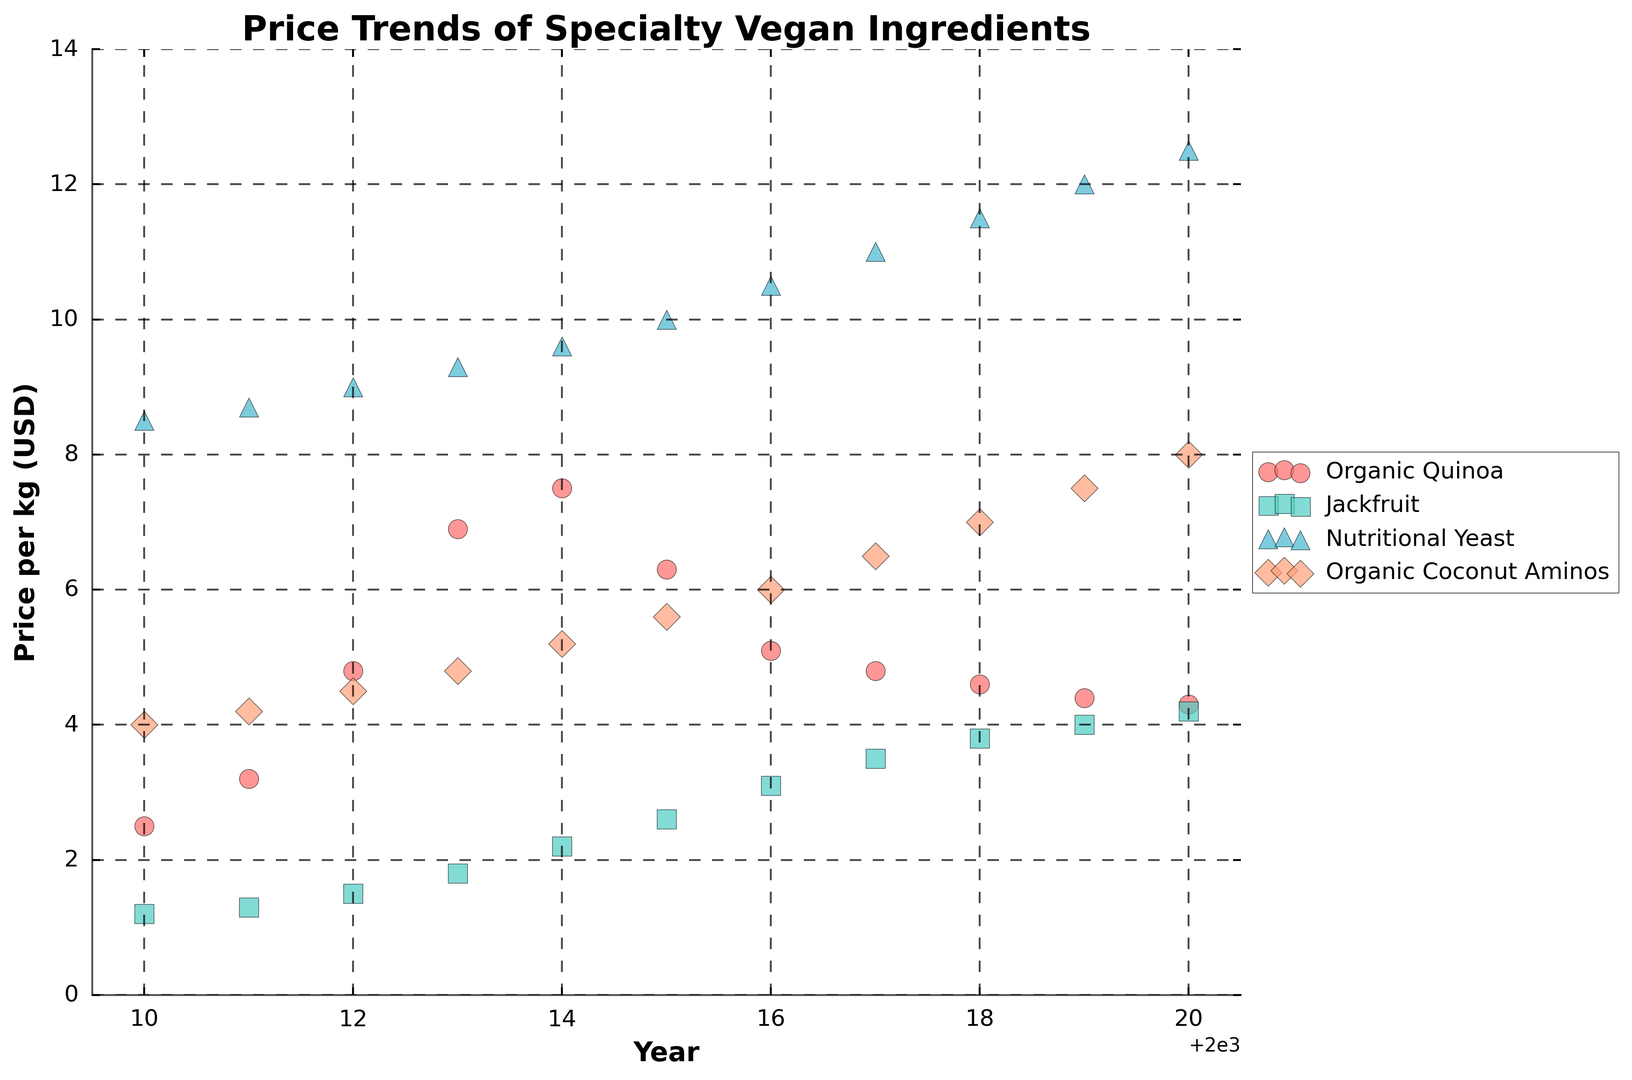Which ingredient had the highest price per kg in 2020? Look at the prices for all ingredients in 2020; Nutritional Yeast had the highest price at $12.50 per kg.
Answer: Nutritional Yeast How did the price of Organic Quinoa change between 2013 and 2018? Compare the price of Organic Quinoa in 2013 ($6.90) and 2018 ($4.60); the price decreased by $2.30.
Answer: Decreased by $2.30 Which ingredient showed a consistent price increase over the years? Observe the trends; Nutritional Yeast consistently increased in price every year from 2010 to 2020.
Answer: Nutritional Yeast Between 2015 and 2020, which ingredient had the highest percentage increase in price? Calculate percentage increase: for Organic Quinoa (4.30/6.30 - 1 ≈ -31.75% decrease), Jackfruit (4.20/2.60 - 1 ≈ 61.54%), Nutritional Yeast (12.50/10.00 - 1 ≈ 25%), Organic Coconut Aminos (8.00/5.60 - 1 ≈ 42.86%). Jackfruit had the highest increase.
Answer: Jackfruit Which ingredient had the most stable price trend over the decade? Evaluate the plotted prices; Organic Quinoa showed variability, whereas Nutritional Yeast showed consistent, steady increase.
Answer: Nutritional Yeast What was the average price per kg of Organic Coconut Aminos over 2010-2020? Sum prices from each year: $4.00 + $4.20 + $4.50 + $4.80 + $5.20 + $5.60 + $6.00 + $6.50 + $7.00 + $7.50 + $8.00 = $63.30. Average is $63.30/11 ≈ $5.75
Answer: $5.75 Which year saw the largest price increase for Jackfruit? Compare year-to-year price differences for Jackfruit; 2015-2016 saw the biggest increase from $2.60 to $3.10, an increase of $0.50.
Answer: Between 2015 and 2016 Between 2010 and 2020, which ingredient had the smallest difference between its highest and lowest prices? Review the range: Organic Quinoa ($7.50-$2.50=$5.00), Jackfruit ($4.20-$1.20=$3.00), Nutritional Yeast ($12.50-$8.50=$4.00), Organic Coconut Aminos ($8.00-$4.00=$4.00). Jackfruit had the smallest difference.
Answer: Jackfruit In 2014, which ingredient was more expensive, Jackfruit or Organic Coconut Aminos? Compare prices in 2014; Jackfruit was $2.20 per kg and Organic Coconut Aminos was $5.20 per kg.
Answer: Organic Coconut Aminos Comparing 2015 prices, which ingredient was the cheapest? Look at 2015 prices: Organic Quinoa ($6.30), Jackfruit ($2.60), Nutritional Yeast ($10.00), Organic Coconut Aminos ($5.60). Jackfruit was the cheapest.
Answer: Jackfruit 